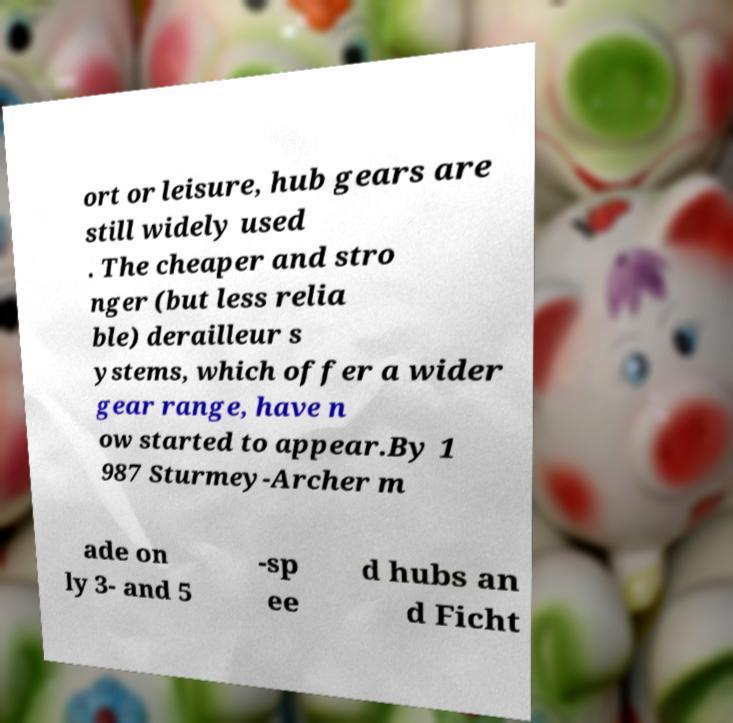Could you assist in decoding the text presented in this image and type it out clearly? ort or leisure, hub gears are still widely used . The cheaper and stro nger (but less relia ble) derailleur s ystems, which offer a wider gear range, have n ow started to appear.By 1 987 Sturmey-Archer m ade on ly 3- and 5 -sp ee d hubs an d Ficht 